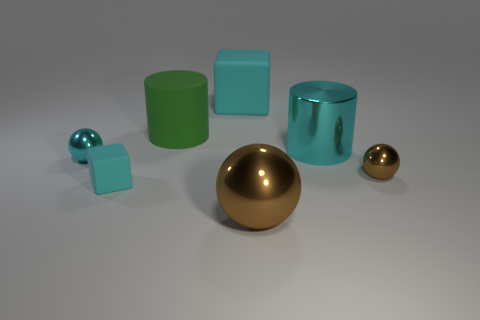Which object in the image is the largest by volume, and what does this imply about its mass? The large cyan cylinder is the biggest by volume. Assuming all objects are made of the same material, this suggests that the cylinder would also have the greatest mass. 